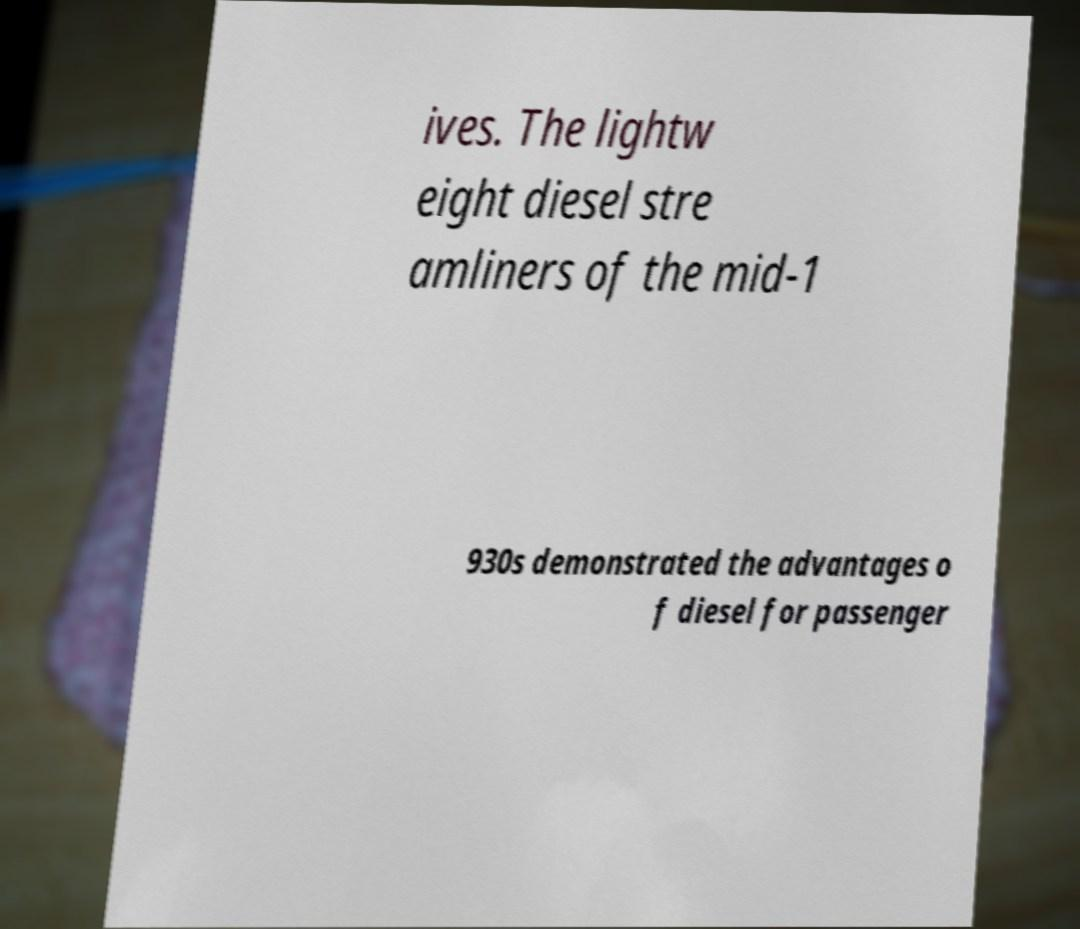Could you assist in decoding the text presented in this image and type it out clearly? ives. The lightw eight diesel stre amliners of the mid-1 930s demonstrated the advantages o f diesel for passenger 